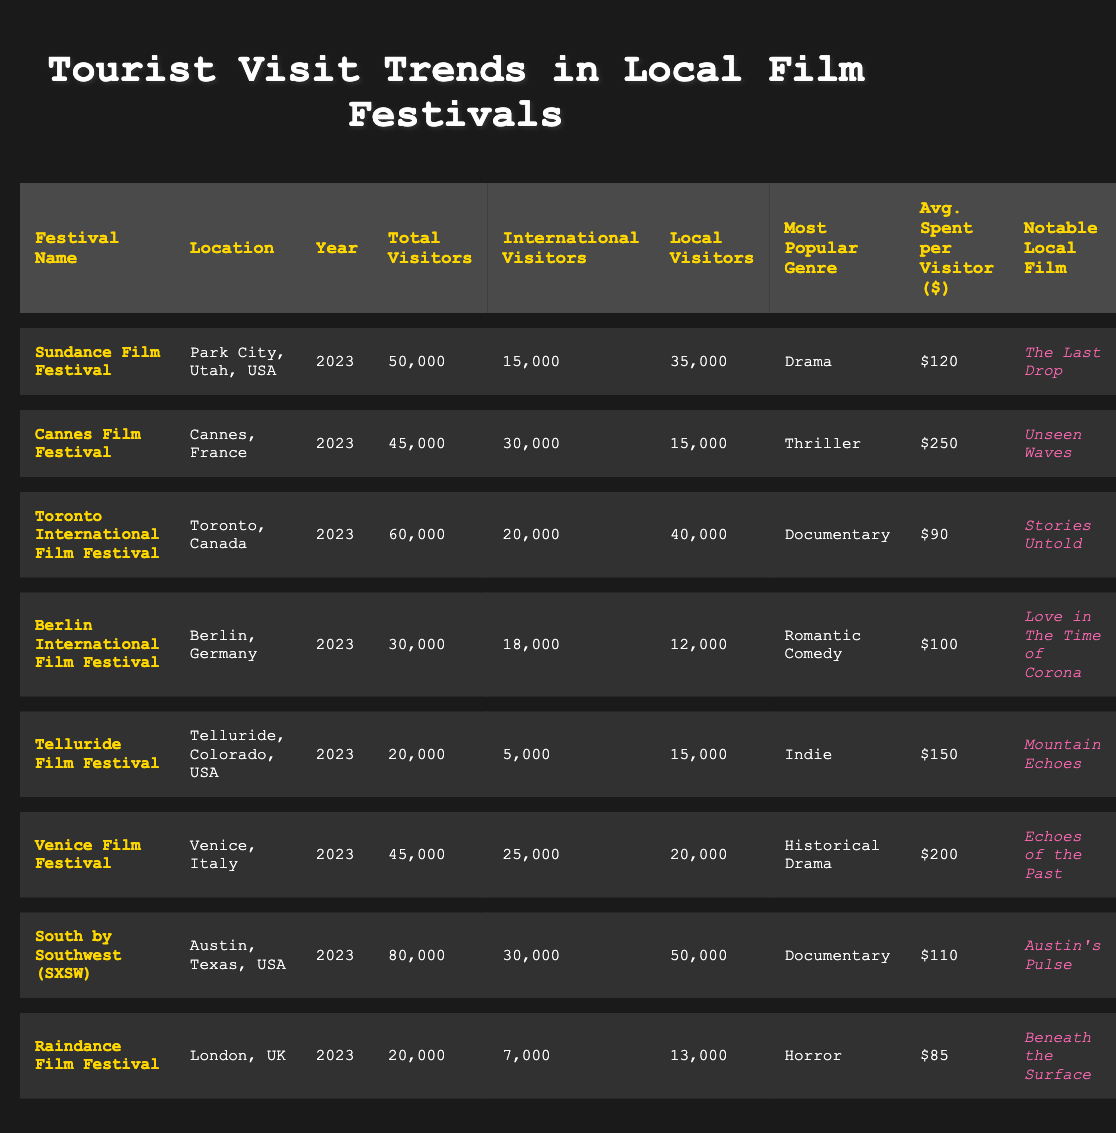What is the total number of visitors at the Toronto International Film Festival? The total number of visitors for the Toronto International Film Festival, as noted in the table, is listed in the 'Total Visitors' column. After locating the row corresponding to the Toronto International Film Festival, the value shown in that column is 60,000.
Answer: 60000 How many local visitors attended the Sundace Film Festival? The 'Local Visitors' column provides the number of local attendees at the Sundance Film Festival. By finding the relevant row in the table, we see that the number of local visitors is 35,000.
Answer: 35000 Which film festival had the highest average spending per visitor? To determine the festival with the highest average spending, we must compare the values in the 'Avg. Spent per Visitor' column for each festival. The highest amount is 250, which corresponds to the Cannes Film Festival.
Answer: Cannes Film Festival Is the most popular genre at the South by Southwest festival documentary? We can answer this by checking the 'Most Popular Genre' column in the row for the South by Southwest festival. The table indicates that the most popular genre there is indeed Documentary.
Answer: Yes What is the combined total of international visitors from the Venice Film Festival and the Cannes Film Festival? We start by locating the 'International Visitors' column values for both the Venice Film Festival (25,000) and the Cannes Film Festival (30,000). We then add these two numbers together: 25,000 + 30,000 = 55,000.
Answer: 55000 Which film festival had the least total visitors and what was that number? The total visitors for each festival must be examined to find the lowest number. Looking through the 'Total Visitors' column, we see that the Telluride Film Festival has the lowest total with 20,000 visitors.
Answer: Telluride Film Festival, 20000 How many more local visitors does the Sundance Film Festival have compared to the Raindance Film Festival? To find this, we subtract the number of local visitors at the Raindance Film Festival (13,000) from that of the Sundance Film Festival (35,000). Hence, the calculation is 35,000 - 13,000 = 22,000.
Answer: 22000 Is the notable local film of the Berlin International Film Festival “Love in The Time of Corona”? By reviewing the 'Notable Local Film' column in the table for the Berlin International Film Festival, we confirm that it is indeed “Love in The Time of Corona”.
Answer: Yes What is the total number of local visitors across all festivals? To calculate this total, we sum the values of the 'Local Visitors' column for each festival: 35,000 (Sundance) + 15,000 (Cannes) + 40,000 (Toronto) + 12,000 (Berlin) + 15,000 (Telluride) + 20,000 (Venice) + 50,000 (SXSW) + 13,000 (Raindance) = 200,000. The total number of local visitors is, therefore, 200,000.
Answer: 200000 